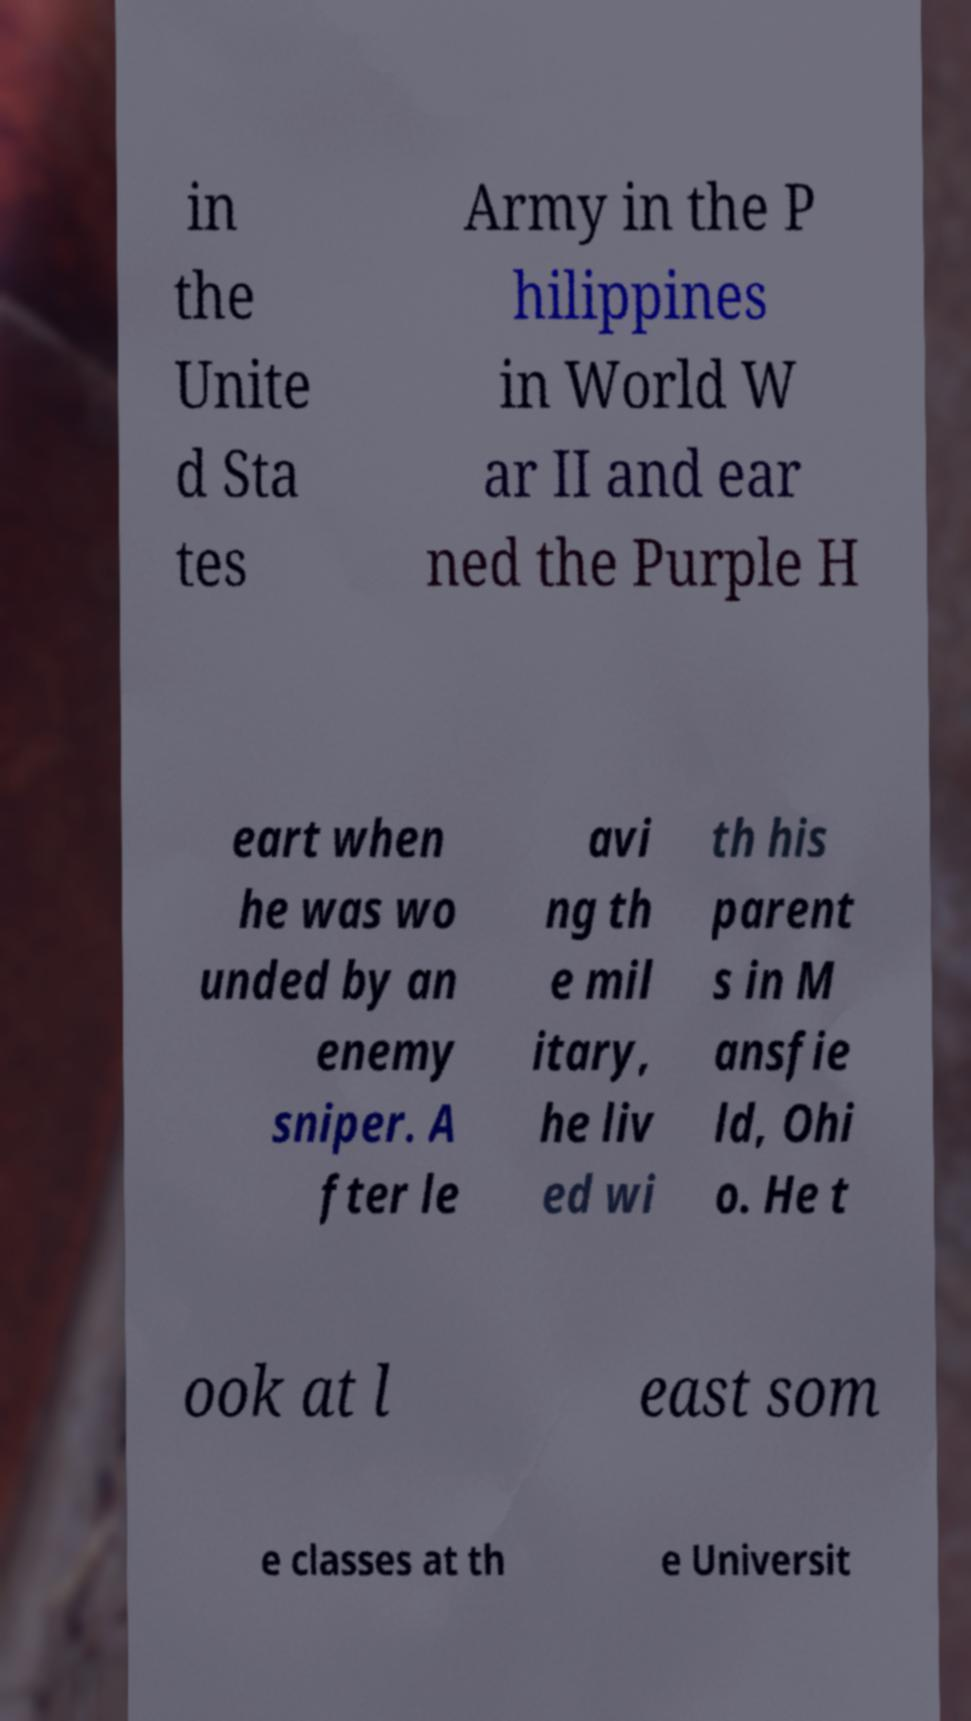Can you read and provide the text displayed in the image?This photo seems to have some interesting text. Can you extract and type it out for me? in the Unite d Sta tes Army in the P hilippines in World W ar II and ear ned the Purple H eart when he was wo unded by an enemy sniper. A fter le avi ng th e mil itary, he liv ed wi th his parent s in M ansfie ld, Ohi o. He t ook at l east som e classes at th e Universit 